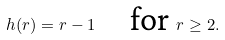<formula> <loc_0><loc_0><loc_500><loc_500>h ( r ) = r - 1 \quad \text {for } r \geq 2 .</formula> 